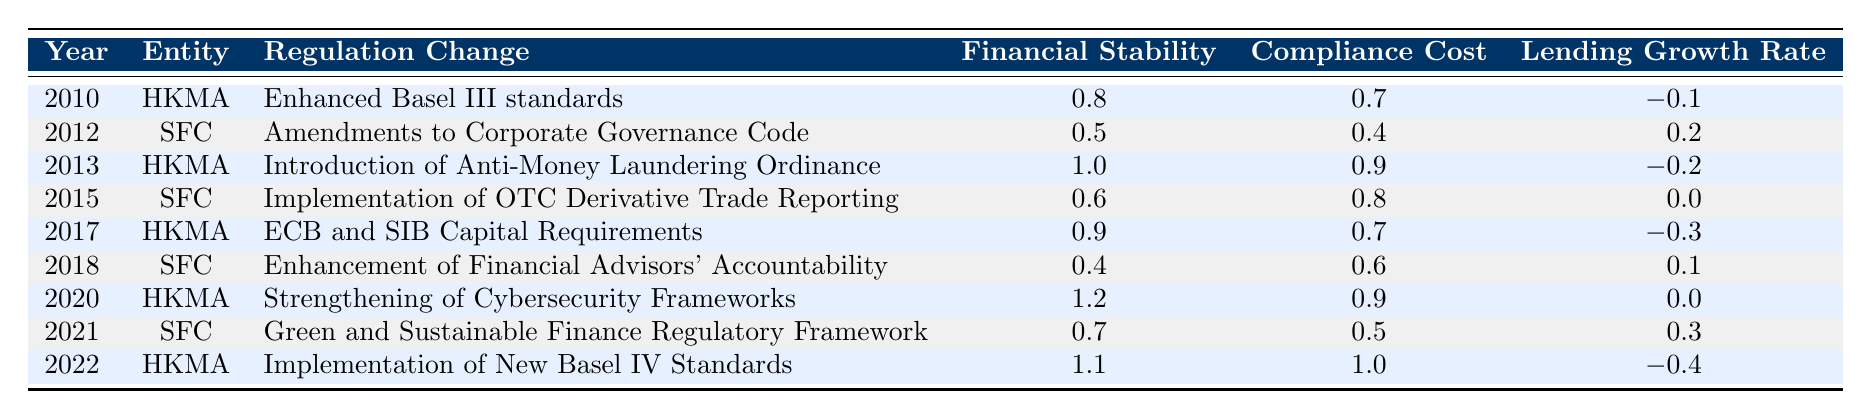What was the economic impact regarding financial stability for the regulatory change in 2015? Referring to the table, the regulation change in 2015 was the "Implementation of OTC Derivative Trade Reporting" by the SFC, which shows a financial stability impact of 0.6.
Answer: 0.6 Which year had the highest compliance cost associated with a regulatory change? By examining the compliance costs in the table, the highest value can be found in 2022 with the "Implementation of New Basel IV Standards" by the HKMA, which shows a compliance cost of 1.0.
Answer: 2022 What is the total lending growth rate impact from the years 2010 to 2022? The lending growth rates from each year are as follows: -0.1 (2010), 0.2 (2012), -0.2 (2013), 0 (2015), -0.3 (2017), 0.1 (2018), 0 (2020), 0.3 (2021), -0.4 (2022). Summing these values gives: -0.1 + 0.2 - 0.2 + 0 - 0.3 + 0.1 + 0 + 0.3 - 0.4 = -0.4.
Answer: -0.4 Did the financial stability impact improve after 2020? Comparing the financial stability impacts of 2020 (1.2) and 2021 (0.7), it shows a decrease from 1.2 to 0.7, indicating it did not improve after 2020.
Answer: No What is the average compliance cost for regulatory changes enacted by the HKMA? The compliance costs for HKMA changes are: 0.7 (2010), 0.9 (2013), 0.9 (2020), and 1.0 (2022). Adding these gives: 0.7 + 0.9 + 0.9 + 1.0 = 3.5. There are 4 entries, so the average is 3.5 / 4 = 0.875.
Answer: 0.875 Which regulation change resulted in the worst lending growth rate and what was it? The lending growth rates show the worst impact as -0.4 from the 2022 change, "Implementation of New Basel IV Standards" by HKMA, indicating it had the most negative effect on lending growth.
Answer: Implementation of New Basel IV Standards; -0.4 What were the financial stability impacts of the regulation changes made by the SFC from 2010 to 2022? Referring to the table, the financial stability impacts from SFC are: 0.5 (2012), 0.6 (2015), and 0.7 (2021). This demonstrates a gradual increase over the years.
Answer: 0.5, 0.6, 0.7 How many regulatory changes had a compliance cost of 0.4 or lower? Looking through the compliance cost data, the only value at or below 0.4 is 0.4 itself (2012). Thus, there is one regulatory change that meets this criterion.
Answer: 1 